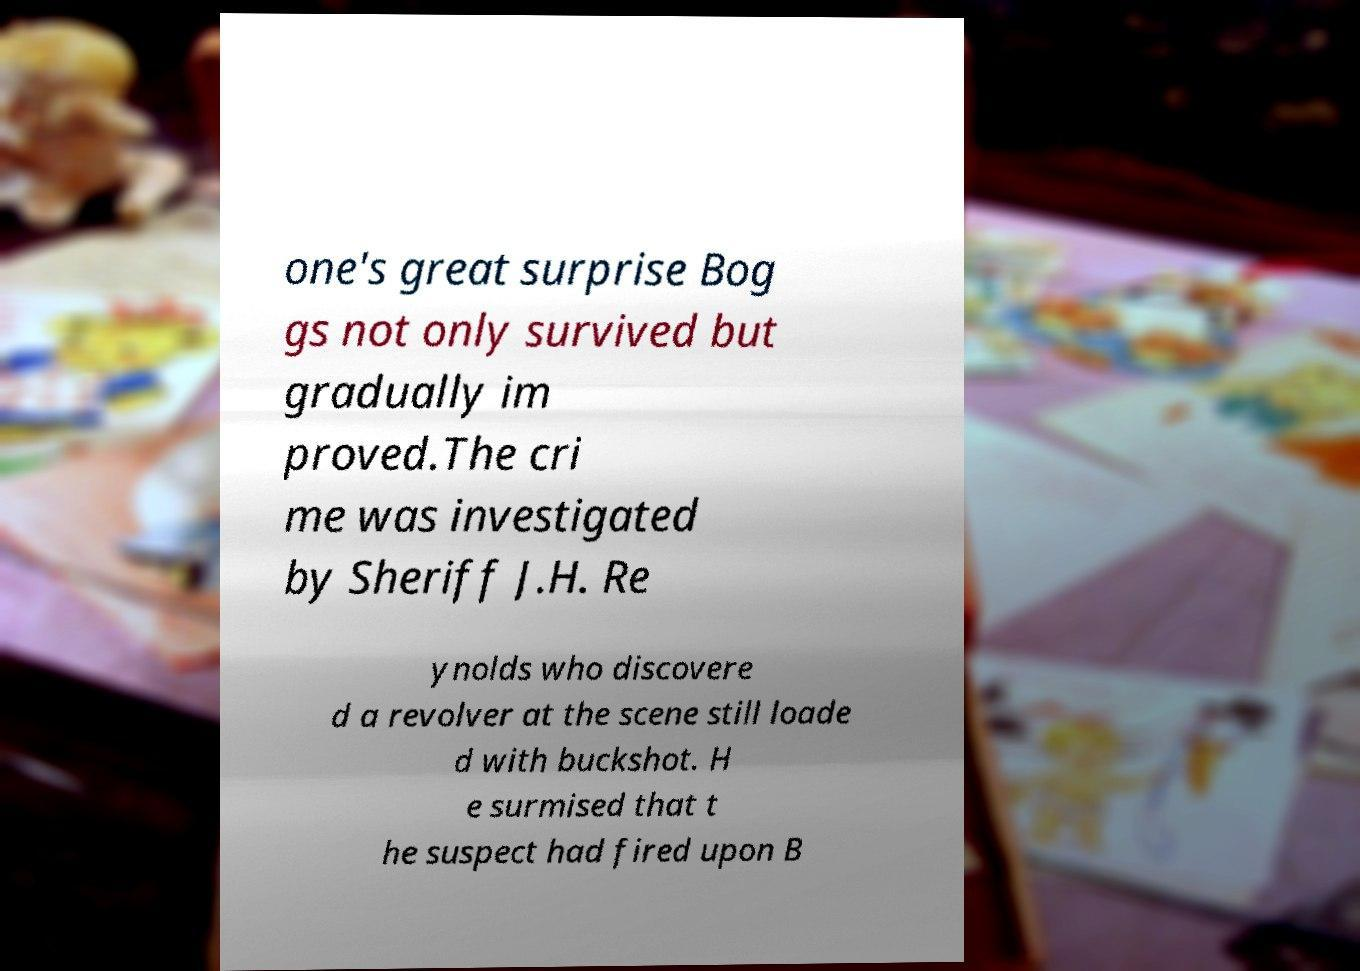Please identify and transcribe the text found in this image. one's great surprise Bog gs not only survived but gradually im proved.The cri me was investigated by Sheriff J.H. Re ynolds who discovere d a revolver at the scene still loade d with buckshot. H e surmised that t he suspect had fired upon B 